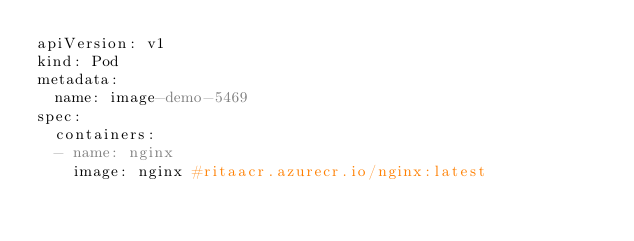Convert code to text. <code><loc_0><loc_0><loc_500><loc_500><_YAML_>apiVersion: v1
kind: Pod
metadata:
  name: image-demo-5469
spec:
  containers:
  - name: nginx
    image: nginx #ritaacr.azurecr.io/nginx:latest</code> 